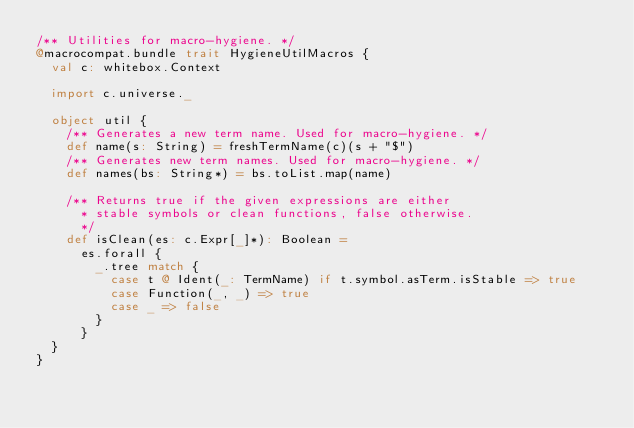<code> <loc_0><loc_0><loc_500><loc_500><_Scala_>/** Utilities for macro-hygiene. */
@macrocompat.bundle trait HygieneUtilMacros {
  val c: whitebox.Context

  import c.universe._

  object util {
    /** Generates a new term name. Used for macro-hygiene. */
    def name(s: String) = freshTermName(c)(s + "$")
    /** Generates new term names. Used for macro-hygiene. */
    def names(bs: String*) = bs.toList.map(name)

    /** Returns true if the given expressions are either
      * stable symbols or clean functions, false otherwise.
      */
    def isClean(es: c.Expr[_]*): Boolean =
      es.forall {
        _.tree match {
          case t @ Ident(_: TermName) if t.symbol.asTerm.isStable => true
          case Function(_, _) => true
          case _ => false
        }
      }
  }
}
</code> 